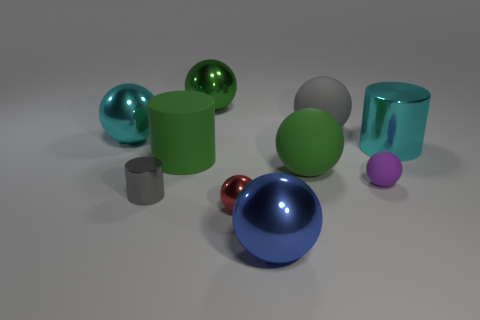Are there any cylinders of the same size as the blue object?
Offer a very short reply. Yes. Do the small thing behind the small gray cylinder and the large blue object have the same shape?
Your response must be concise. Yes. Does the tiny red shiny thing have the same shape as the small gray object?
Keep it short and to the point. No. Are there any small brown things that have the same shape as the tiny purple thing?
Your response must be concise. No. What is the shape of the large green matte thing that is behind the large green matte thing that is right of the blue thing?
Offer a very short reply. Cylinder. The big metal object on the right side of the small matte thing is what color?
Keep it short and to the point. Cyan. There is a gray object that is the same material as the red thing; what is its size?
Provide a short and direct response. Small. What size is the gray object that is the same shape as the blue metal thing?
Your answer should be compact. Large. Are any tiny purple objects visible?
Give a very brief answer. Yes. How many things are either big cyan things left of the gray cylinder or purple balls?
Give a very brief answer. 2. 